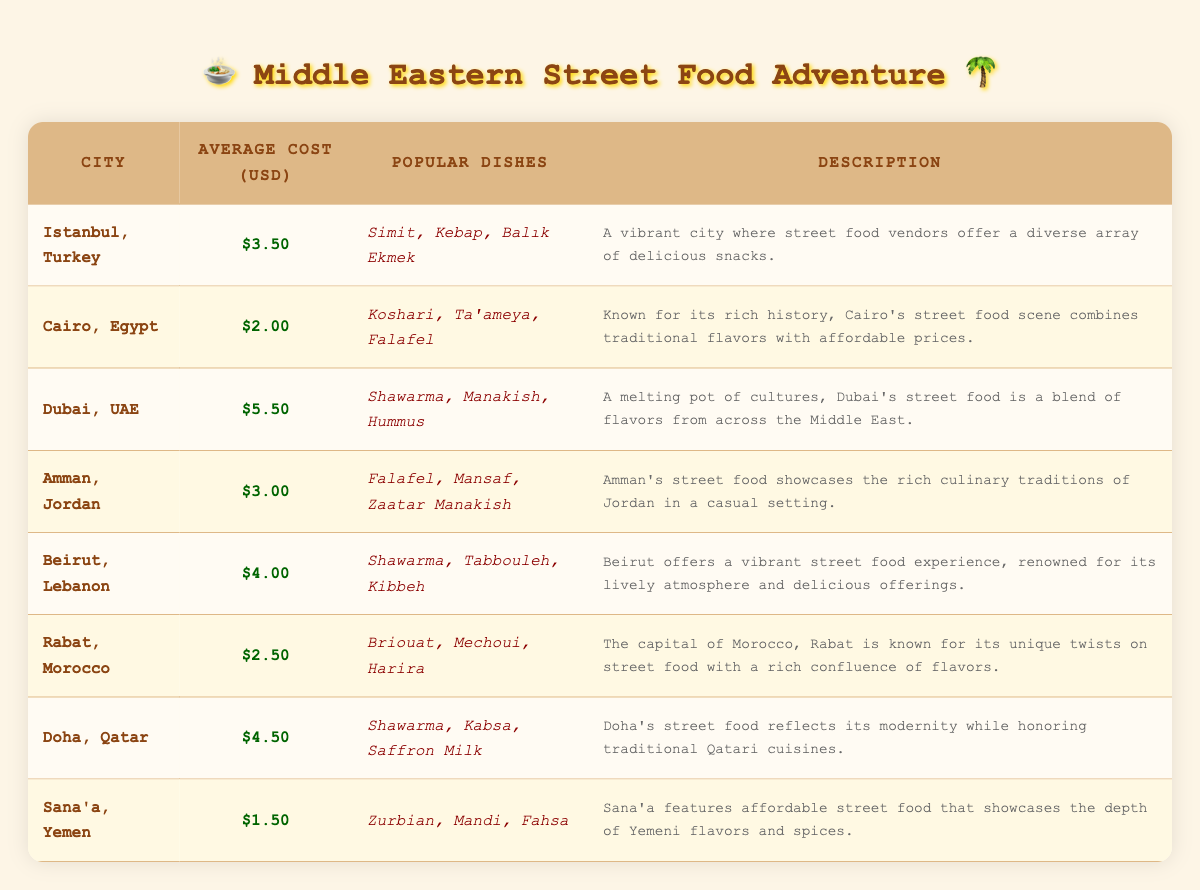What is the average cost of street food in Cairo, Egypt? The table lists Cairo, Egypt with an average cost of street food at $2.00
Answer: $2.00 Which city has the highest average cost for street food? Looking at the average costs listed, Dubai, UAE has the highest average cost at $5.50
Answer: Dubai, UAE How many cities have an average cost of street food below $3.00? The cities with average costs below $3.00 are Cairo ($2.00), Rabat ($2.50), and Sana'a ($1.50), which totals 3 cities.
Answer: 3 What is the difference in average cost between street food in Dubai and Sana'a? The average cost in Dubai is $5.50, and in Sana'a, it is $1.50. The difference is $5.50 - $1.50 = $4.00
Answer: $4.00 List the popular dishes in Amman, Jordan. The table shows that the popular dishes in Amman are Falafel, Mansaf, and Zaatar Manakish
Answer: Falafel, Mansaf, Zaatar Manakish Does Beirut, Lebanon have a higher average cost than Rabat, Morocco? The table shows Beirut's average cost is $4.00, and Rabat's average is $2.50. Since 4.00 is greater than 2.50, the answer is yes.
Answer: Yes Which city has the most popular dishes listed and what are they? The city with the most popular dishes is Istanbul, Turkey, with Simit, Kebap, and Balık Ekmek listed.
Answer: Istanbul, Turkey; Simit, Kebap, Balık Ekmek Calculate the average cost of street food in the five cities with the lowest costs. The five cities with the lowest costs are Sana'a ($1.50), Cairo ($2.00), Rabat ($2.50), Amman ($3.00), and Istanbul ($3.50). Sum of costs = $1.50 + $2.00 + $2.50 + $3.00 + $3.50 = $12.50. There are 5 cities, so the average is $12.50 / 5 = $2.50
Answer: $2.50 Which city is known for a blend of flavors from across the Middle East? The table states that Dubai, UAE is recognized for being a melting pot of cultures and flavors from across the Middle East.
Answer: Dubai, UAE Is the average cost of street food in Doha lower than the average cost in Beirut? The average cost in Doha is $4.50 and in Beirut it is $4.00. Since $4.50 is higher than $4.00, the answer is no.
Answer: No 